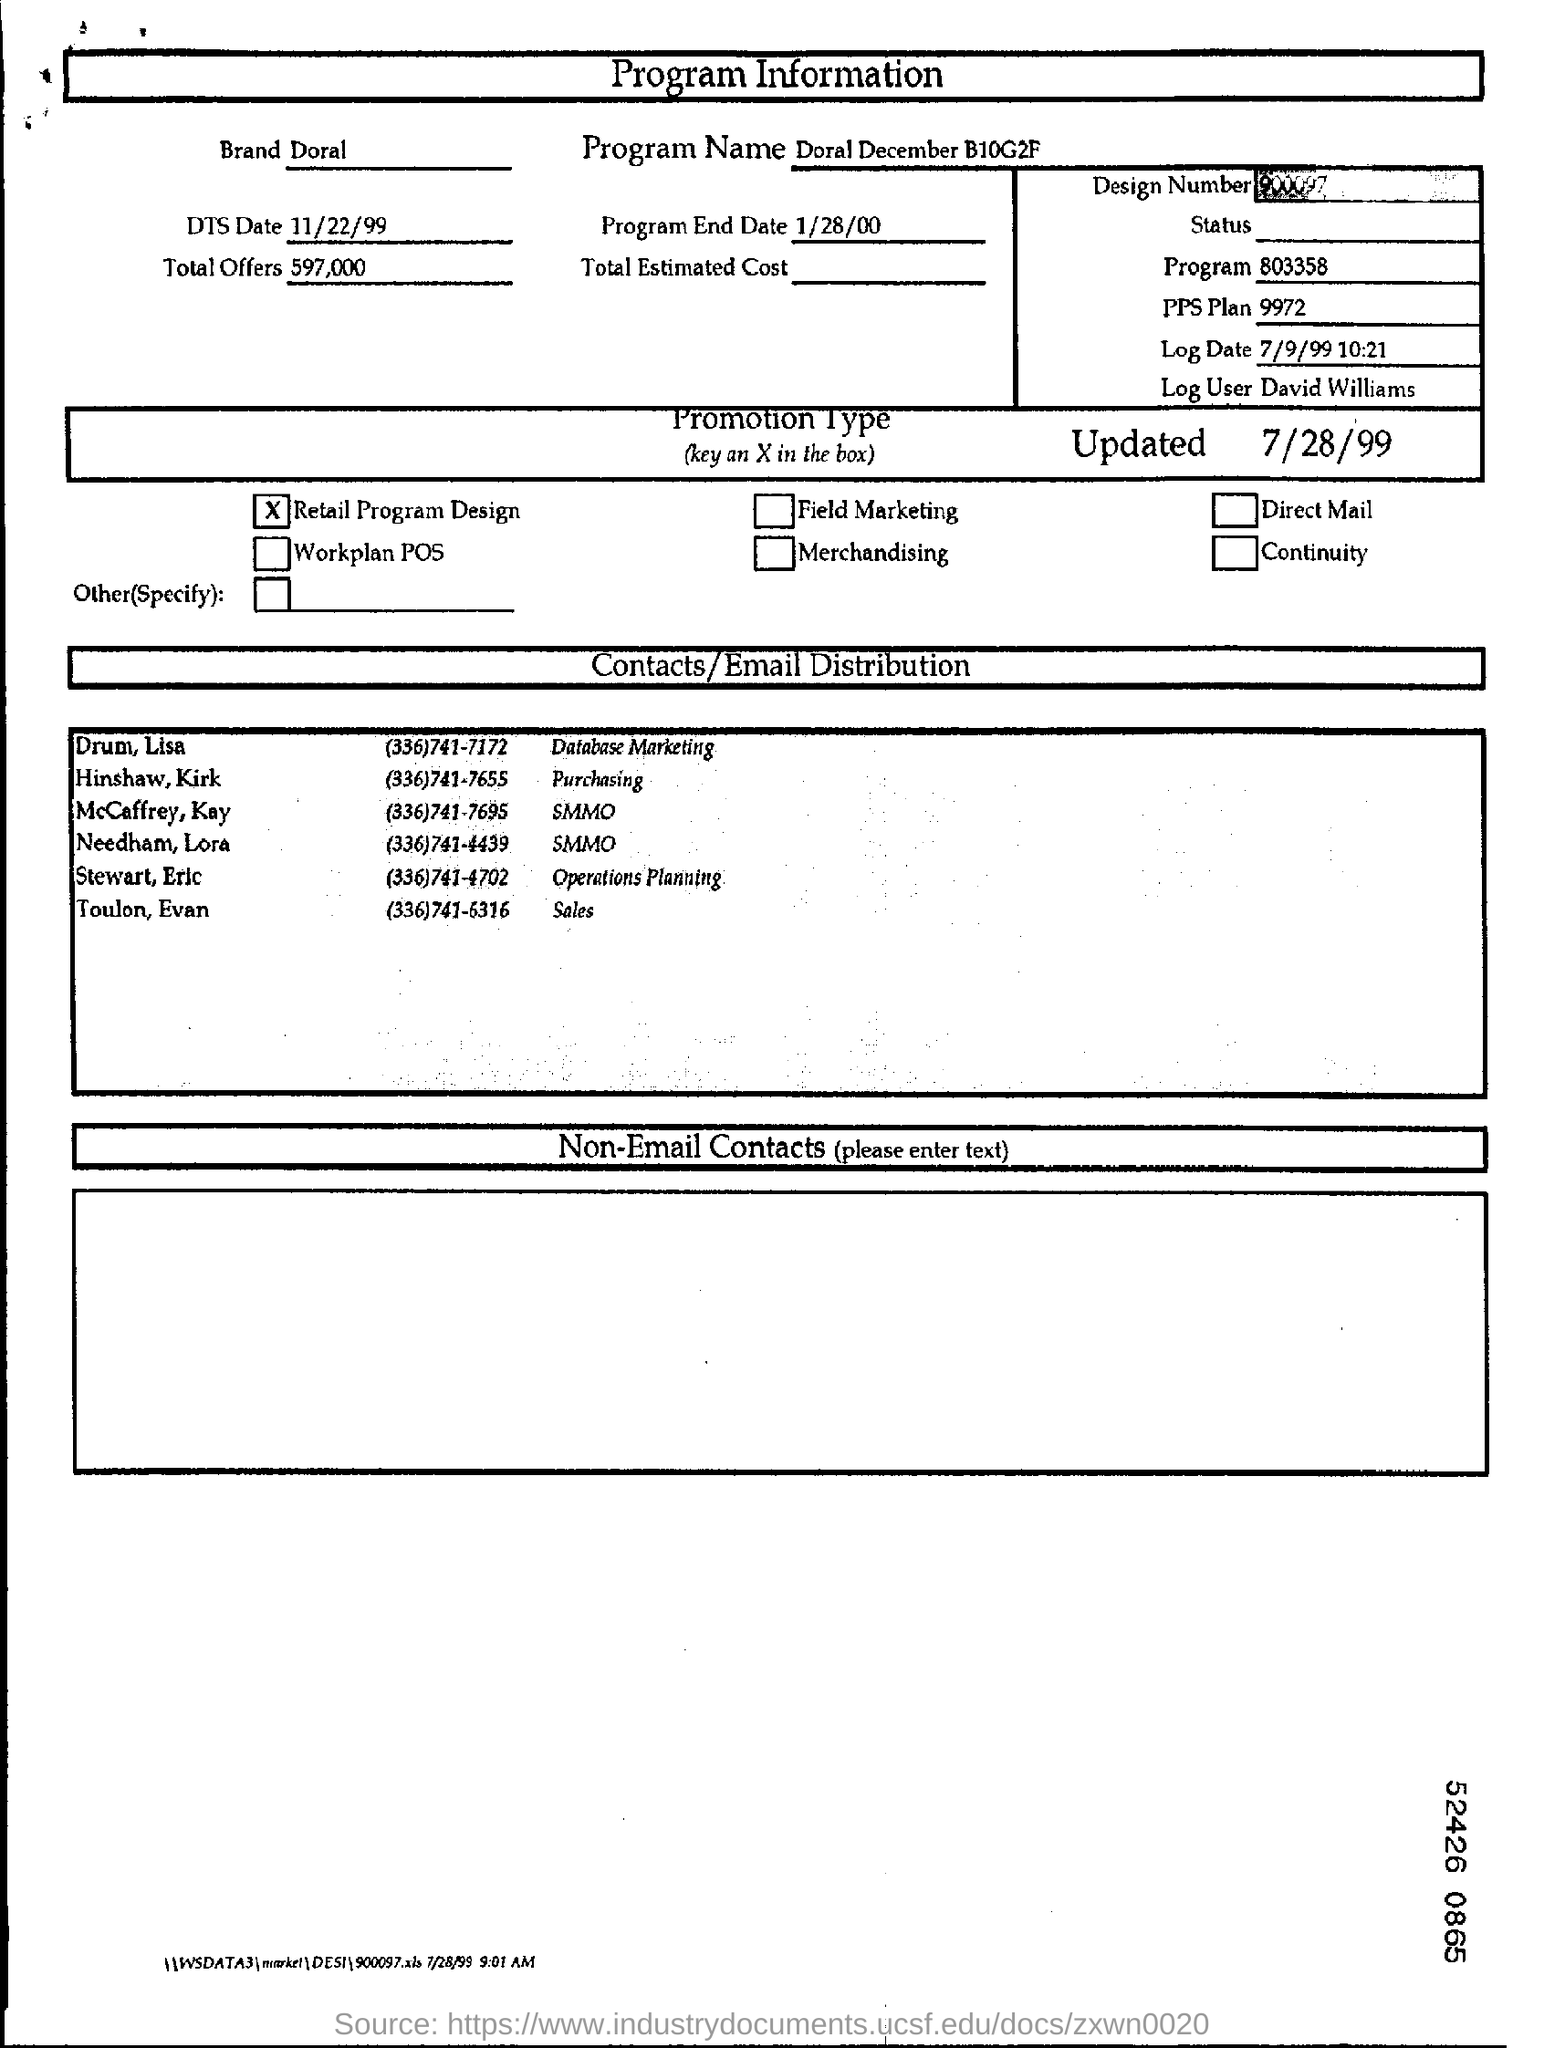Indicate a few pertinent items in this graphic. It is necessary to contact Dr. Lisa Drum regarding database marketing. The promotion type is retail program design. Doral is the brand that was mentioned in the program information. There are approximately 597,000 total offers mentioned in the form. The program name is Doral December B10G2F. 